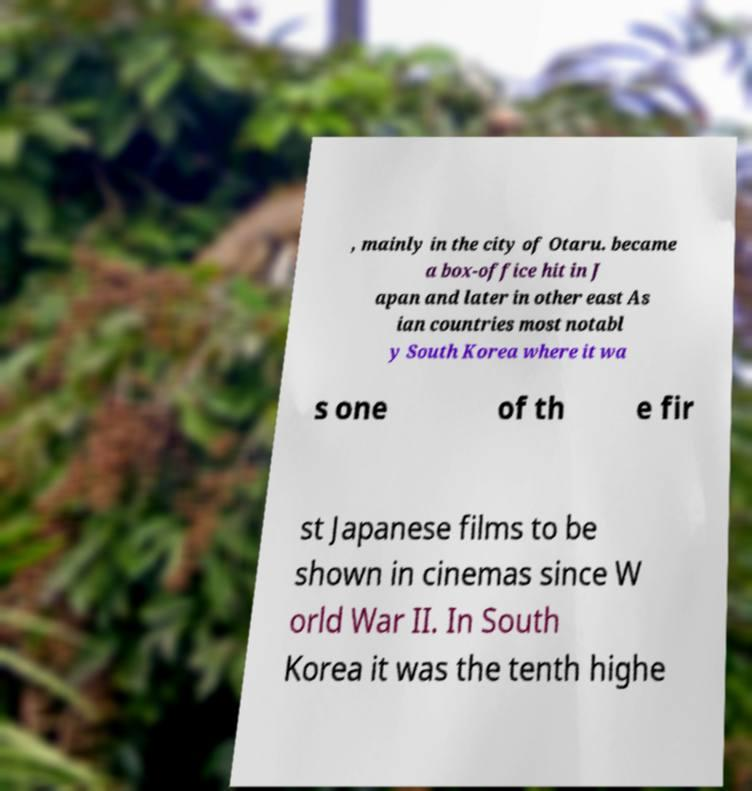Can you accurately transcribe the text from the provided image for me? , mainly in the city of Otaru. became a box-office hit in J apan and later in other east As ian countries most notabl y South Korea where it wa s one of th e fir st Japanese films to be shown in cinemas since W orld War II. In South Korea it was the tenth highe 